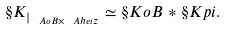Convert formula to latex. <formula><loc_0><loc_0><loc_500><loc_500>\S K _ { | _ { \ A o B \times \ A h e i z } } \simeq \S K o B \ast \S K p i .</formula> 